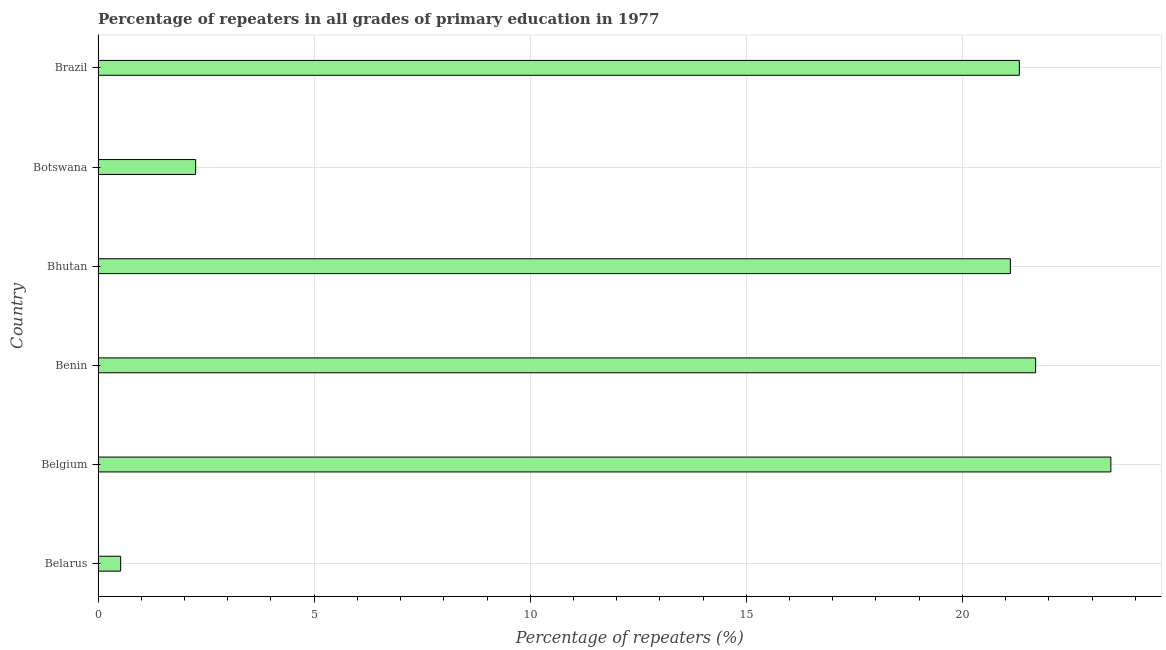What is the title of the graph?
Make the answer very short. Percentage of repeaters in all grades of primary education in 1977. What is the label or title of the X-axis?
Offer a very short reply. Percentage of repeaters (%). What is the label or title of the Y-axis?
Offer a terse response. Country. What is the percentage of repeaters in primary education in Benin?
Offer a terse response. 21.69. Across all countries, what is the maximum percentage of repeaters in primary education?
Make the answer very short. 23.43. Across all countries, what is the minimum percentage of repeaters in primary education?
Your response must be concise. 0.52. In which country was the percentage of repeaters in primary education minimum?
Offer a terse response. Belarus. What is the sum of the percentage of repeaters in primary education?
Ensure brevity in your answer.  90.34. What is the difference between the percentage of repeaters in primary education in Benin and Botswana?
Provide a succinct answer. 19.44. What is the average percentage of repeaters in primary education per country?
Offer a terse response. 15.06. What is the median percentage of repeaters in primary education?
Provide a succinct answer. 21.21. What is the ratio of the percentage of repeaters in primary education in Belarus to that in Bhutan?
Offer a very short reply. 0.03. Is the percentage of repeaters in primary education in Belarus less than that in Botswana?
Provide a succinct answer. Yes. Is the difference between the percentage of repeaters in primary education in Belarus and Belgium greater than the difference between any two countries?
Give a very brief answer. Yes. What is the difference between the highest and the second highest percentage of repeaters in primary education?
Offer a very short reply. 1.74. Is the sum of the percentage of repeaters in primary education in Belgium and Bhutan greater than the maximum percentage of repeaters in primary education across all countries?
Offer a very short reply. Yes. What is the difference between the highest and the lowest percentage of repeaters in primary education?
Give a very brief answer. 22.91. Are all the bars in the graph horizontal?
Ensure brevity in your answer.  Yes. What is the Percentage of repeaters (%) of Belarus?
Offer a terse response. 0.52. What is the Percentage of repeaters (%) in Belgium?
Your response must be concise. 23.43. What is the Percentage of repeaters (%) of Benin?
Your answer should be compact. 21.69. What is the Percentage of repeaters (%) in Bhutan?
Offer a very short reply. 21.11. What is the Percentage of repeaters (%) in Botswana?
Give a very brief answer. 2.26. What is the Percentage of repeaters (%) of Brazil?
Provide a short and direct response. 21.32. What is the difference between the Percentage of repeaters (%) in Belarus and Belgium?
Offer a terse response. -22.91. What is the difference between the Percentage of repeaters (%) in Belarus and Benin?
Ensure brevity in your answer.  -21.17. What is the difference between the Percentage of repeaters (%) in Belarus and Bhutan?
Make the answer very short. -20.59. What is the difference between the Percentage of repeaters (%) in Belarus and Botswana?
Ensure brevity in your answer.  -1.73. What is the difference between the Percentage of repeaters (%) in Belarus and Brazil?
Keep it short and to the point. -20.8. What is the difference between the Percentage of repeaters (%) in Belgium and Benin?
Offer a terse response. 1.74. What is the difference between the Percentage of repeaters (%) in Belgium and Bhutan?
Your answer should be very brief. 2.33. What is the difference between the Percentage of repeaters (%) in Belgium and Botswana?
Provide a succinct answer. 21.18. What is the difference between the Percentage of repeaters (%) in Belgium and Brazil?
Provide a short and direct response. 2.12. What is the difference between the Percentage of repeaters (%) in Benin and Bhutan?
Provide a succinct answer. 0.58. What is the difference between the Percentage of repeaters (%) in Benin and Botswana?
Provide a succinct answer. 19.44. What is the difference between the Percentage of repeaters (%) in Benin and Brazil?
Offer a terse response. 0.38. What is the difference between the Percentage of repeaters (%) in Bhutan and Botswana?
Offer a terse response. 18.85. What is the difference between the Percentage of repeaters (%) in Bhutan and Brazil?
Your answer should be very brief. -0.21. What is the difference between the Percentage of repeaters (%) in Botswana and Brazil?
Provide a short and direct response. -19.06. What is the ratio of the Percentage of repeaters (%) in Belarus to that in Belgium?
Your answer should be compact. 0.02. What is the ratio of the Percentage of repeaters (%) in Belarus to that in Benin?
Provide a short and direct response. 0.02. What is the ratio of the Percentage of repeaters (%) in Belarus to that in Bhutan?
Your answer should be compact. 0.03. What is the ratio of the Percentage of repeaters (%) in Belarus to that in Botswana?
Keep it short and to the point. 0.23. What is the ratio of the Percentage of repeaters (%) in Belarus to that in Brazil?
Provide a short and direct response. 0.03. What is the ratio of the Percentage of repeaters (%) in Belgium to that in Benin?
Ensure brevity in your answer.  1.08. What is the ratio of the Percentage of repeaters (%) in Belgium to that in Bhutan?
Ensure brevity in your answer.  1.11. What is the ratio of the Percentage of repeaters (%) in Belgium to that in Botswana?
Offer a very short reply. 10.38. What is the ratio of the Percentage of repeaters (%) in Belgium to that in Brazil?
Make the answer very short. 1.1. What is the ratio of the Percentage of repeaters (%) in Benin to that in Bhutan?
Offer a very short reply. 1.03. What is the ratio of the Percentage of repeaters (%) in Benin to that in Botswana?
Provide a short and direct response. 9.61. What is the ratio of the Percentage of repeaters (%) in Benin to that in Brazil?
Make the answer very short. 1.02. What is the ratio of the Percentage of repeaters (%) in Bhutan to that in Botswana?
Provide a succinct answer. 9.35. What is the ratio of the Percentage of repeaters (%) in Bhutan to that in Brazil?
Your answer should be compact. 0.99. What is the ratio of the Percentage of repeaters (%) in Botswana to that in Brazil?
Make the answer very short. 0.11. 